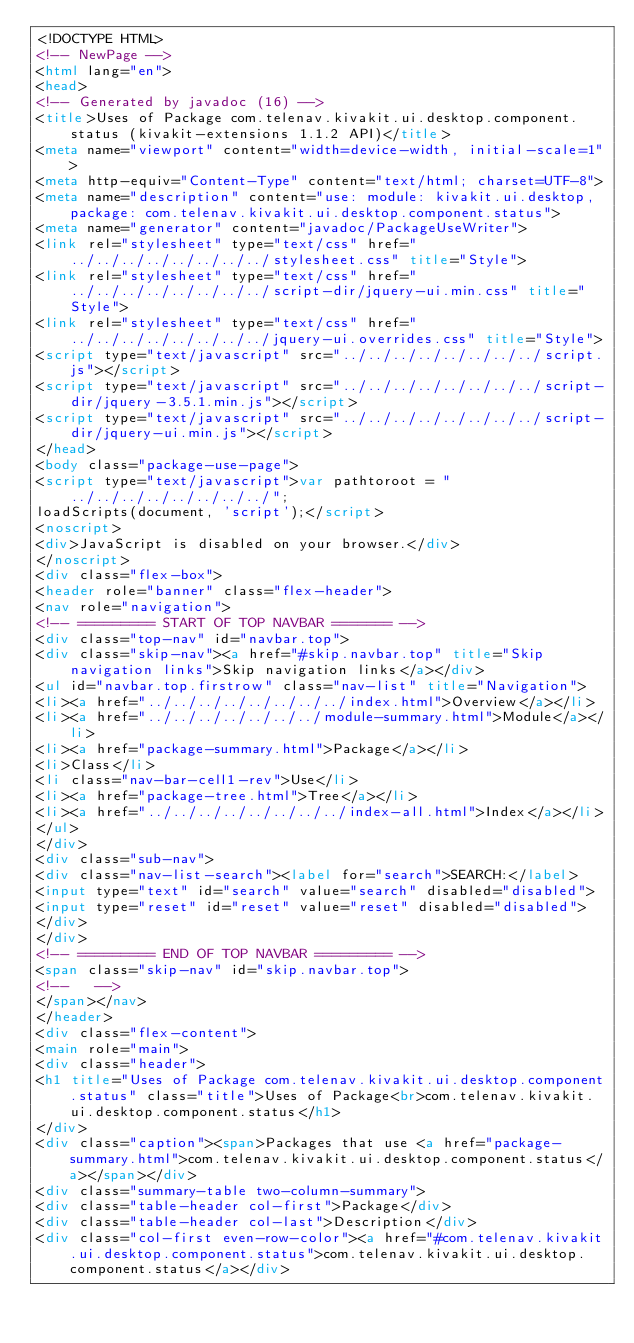<code> <loc_0><loc_0><loc_500><loc_500><_HTML_><!DOCTYPE HTML>
<!-- NewPage -->
<html lang="en">
<head>
<!-- Generated by javadoc (16) -->
<title>Uses of Package com.telenav.kivakit.ui.desktop.component.status (kivakit-extensions 1.1.2 API)</title>
<meta name="viewport" content="width=device-width, initial-scale=1">
<meta http-equiv="Content-Type" content="text/html; charset=UTF-8">
<meta name="description" content="use: module: kivakit.ui.desktop, package: com.telenav.kivakit.ui.desktop.component.status">
<meta name="generator" content="javadoc/PackageUseWriter">
<link rel="stylesheet" type="text/css" href="../../../../../../../../stylesheet.css" title="Style">
<link rel="stylesheet" type="text/css" href="../../../../../../../../script-dir/jquery-ui.min.css" title="Style">
<link rel="stylesheet" type="text/css" href="../../../../../../../../jquery-ui.overrides.css" title="Style">
<script type="text/javascript" src="../../../../../../../../script.js"></script>
<script type="text/javascript" src="../../../../../../../../script-dir/jquery-3.5.1.min.js"></script>
<script type="text/javascript" src="../../../../../../../../script-dir/jquery-ui.min.js"></script>
</head>
<body class="package-use-page">
<script type="text/javascript">var pathtoroot = "../../../../../../../../";
loadScripts(document, 'script');</script>
<noscript>
<div>JavaScript is disabled on your browser.</div>
</noscript>
<div class="flex-box">
<header role="banner" class="flex-header">
<nav role="navigation">
<!-- ========= START OF TOP NAVBAR ======= -->
<div class="top-nav" id="navbar.top">
<div class="skip-nav"><a href="#skip.navbar.top" title="Skip navigation links">Skip navigation links</a></div>
<ul id="navbar.top.firstrow" class="nav-list" title="Navigation">
<li><a href="../../../../../../../../index.html">Overview</a></li>
<li><a href="../../../../../../../module-summary.html">Module</a></li>
<li><a href="package-summary.html">Package</a></li>
<li>Class</li>
<li class="nav-bar-cell1-rev">Use</li>
<li><a href="package-tree.html">Tree</a></li>
<li><a href="../../../../../../../../index-all.html">Index</a></li>
</ul>
</div>
<div class="sub-nav">
<div class="nav-list-search"><label for="search">SEARCH:</label>
<input type="text" id="search" value="search" disabled="disabled">
<input type="reset" id="reset" value="reset" disabled="disabled">
</div>
</div>
<!-- ========= END OF TOP NAVBAR ========= -->
<span class="skip-nav" id="skip.navbar.top">
<!--   -->
</span></nav>
</header>
<div class="flex-content">
<main role="main">
<div class="header">
<h1 title="Uses of Package com.telenav.kivakit.ui.desktop.component.status" class="title">Uses of Package<br>com.telenav.kivakit.ui.desktop.component.status</h1>
</div>
<div class="caption"><span>Packages that use <a href="package-summary.html">com.telenav.kivakit.ui.desktop.component.status</a></span></div>
<div class="summary-table two-column-summary">
<div class="table-header col-first">Package</div>
<div class="table-header col-last">Description</div>
<div class="col-first even-row-color"><a href="#com.telenav.kivakit.ui.desktop.component.status">com.telenav.kivakit.ui.desktop.component.status</a></div></code> 